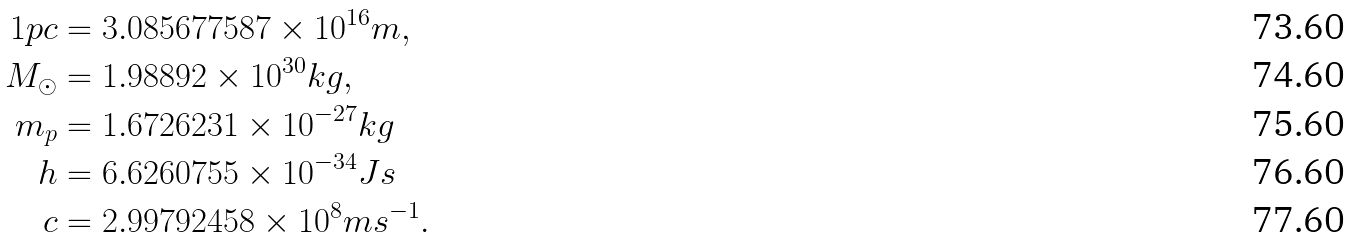Convert formula to latex. <formula><loc_0><loc_0><loc_500><loc_500>1 p c & = 3 . 0 8 5 6 7 7 5 8 7 \times 1 0 ^ { 1 6 } m , \\ M _ { \odot } & = 1 . 9 8 8 9 2 \times 1 0 ^ { 3 0 } k g , \\ m _ { p } & = 1 . 6 7 2 6 2 3 1 \times 1 0 ^ { - 2 7 } k g \\ h & = 6 . 6 2 6 0 7 5 5 \times 1 0 ^ { - 3 4 } J s \\ c & = 2 . 9 9 7 9 2 4 5 8 \times 1 0 ^ { 8 } m s ^ { - 1 } .</formula> 